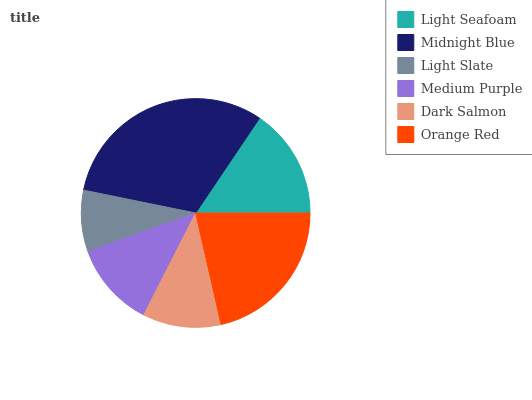Is Light Slate the minimum?
Answer yes or no. Yes. Is Midnight Blue the maximum?
Answer yes or no. Yes. Is Midnight Blue the minimum?
Answer yes or no. No. Is Light Slate the maximum?
Answer yes or no. No. Is Midnight Blue greater than Light Slate?
Answer yes or no. Yes. Is Light Slate less than Midnight Blue?
Answer yes or no. Yes. Is Light Slate greater than Midnight Blue?
Answer yes or no. No. Is Midnight Blue less than Light Slate?
Answer yes or no. No. Is Light Seafoam the high median?
Answer yes or no. Yes. Is Medium Purple the low median?
Answer yes or no. Yes. Is Dark Salmon the high median?
Answer yes or no. No. Is Dark Salmon the low median?
Answer yes or no. No. 